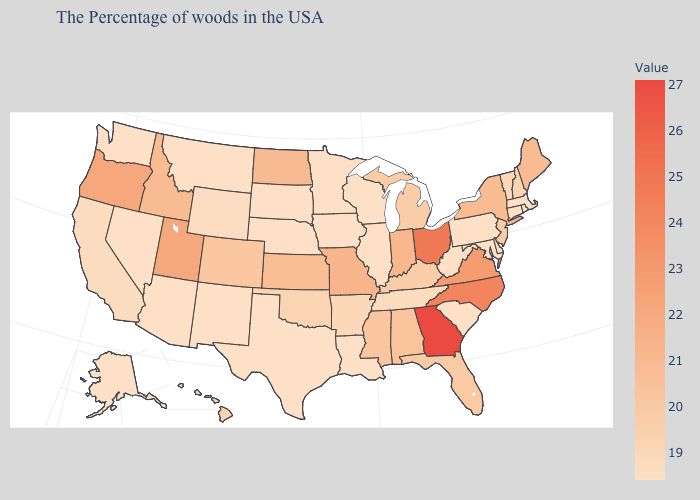Among the states that border Washington , does Idaho have the lowest value?
Quick response, please. Yes. Does Oregon have the highest value in the West?
Write a very short answer. Yes. Does the map have missing data?
Write a very short answer. No. Among the states that border Wyoming , which have the highest value?
Short answer required. Utah. Which states have the highest value in the USA?
Concise answer only. Georgia. 